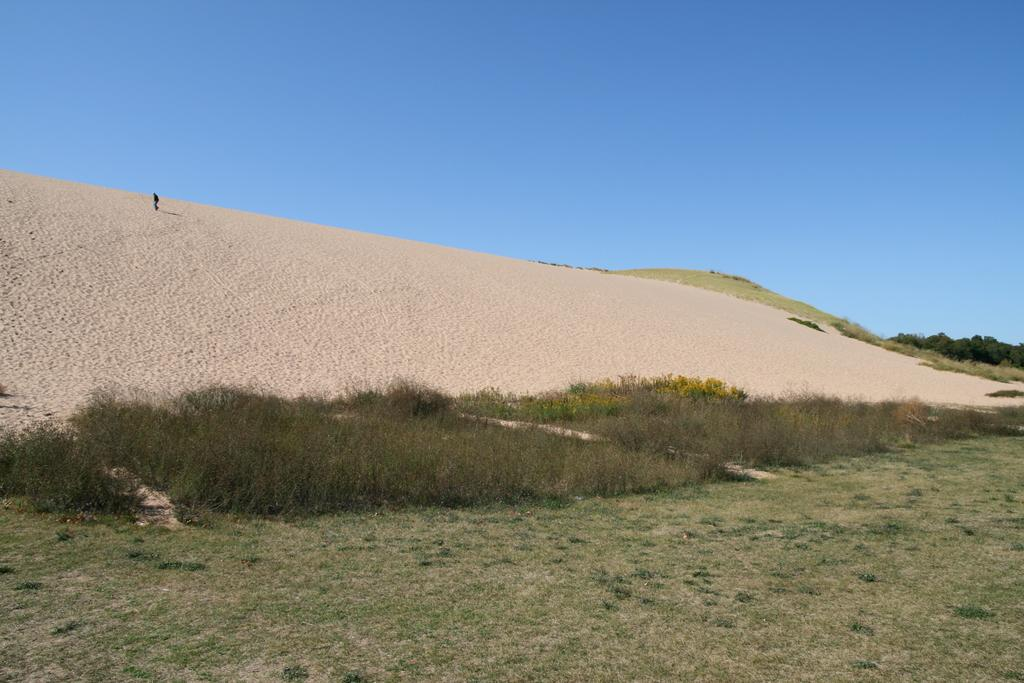What type of vegetation can be seen in the image? There are plants and grass in the image. What natural feature is visible in the image? There is a mountain in the image. What other type of vegetation is present in the image? There are trees in the image. What is visible at the top of the image? The sky is clear at the top of the image. How many kittens are playing the guitar in the image? There are no kittens or guitars present in the image. Can you describe the duck's behavior in the image? There are no ducks present in the image. 